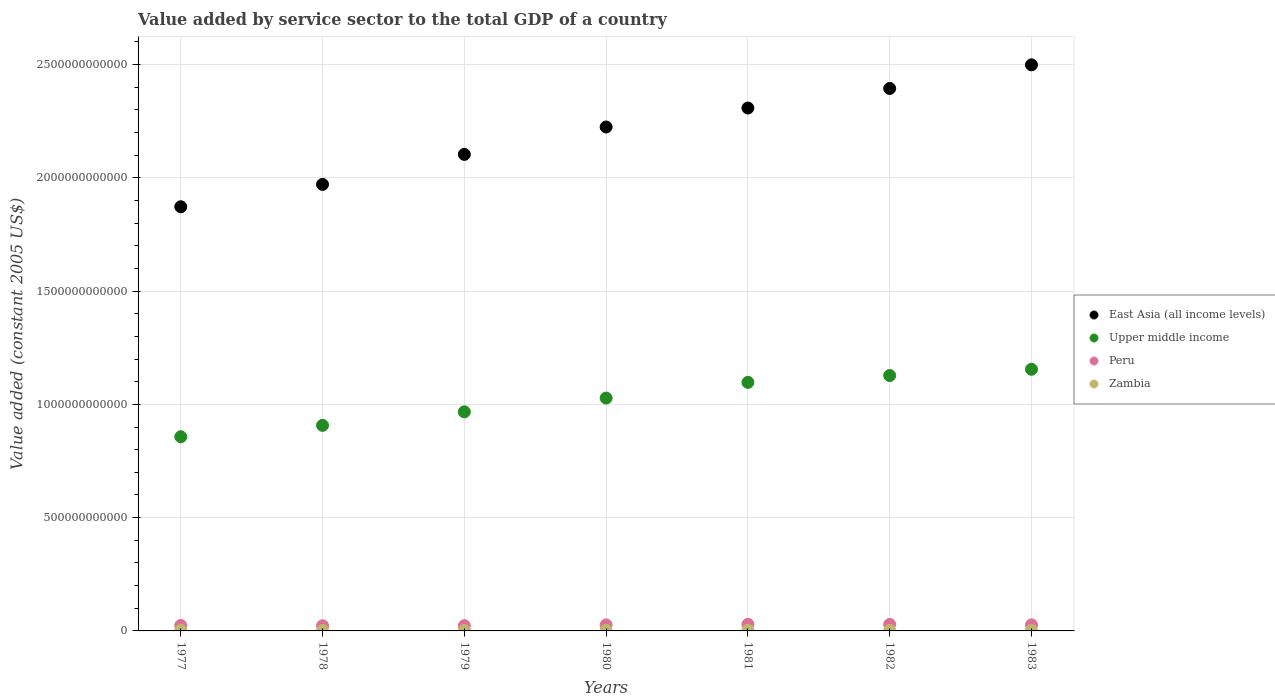Is the number of dotlines equal to the number of legend labels?
Offer a terse response. Yes. What is the value added by service sector in East Asia (all income levels) in 1979?
Your answer should be very brief. 2.10e+12. Across all years, what is the maximum value added by service sector in Peru?
Provide a succinct answer. 2.92e+1. Across all years, what is the minimum value added by service sector in Upper middle income?
Provide a succinct answer. 8.57e+11. In which year was the value added by service sector in Peru maximum?
Offer a very short reply. 1981. In which year was the value added by service sector in Peru minimum?
Your response must be concise. 1978. What is the total value added by service sector in Zambia in the graph?
Your answer should be compact. 1.52e+1. What is the difference between the value added by service sector in East Asia (all income levels) in 1977 and that in 1979?
Your answer should be very brief. -2.31e+11. What is the difference between the value added by service sector in Zambia in 1983 and the value added by service sector in East Asia (all income levels) in 1980?
Offer a very short reply. -2.22e+12. What is the average value added by service sector in Upper middle income per year?
Provide a succinct answer. 1.02e+12. In the year 1980, what is the difference between the value added by service sector in Upper middle income and value added by service sector in Peru?
Make the answer very short. 1.00e+12. What is the ratio of the value added by service sector in Peru in 1981 to that in 1983?
Your answer should be very brief. 1.09. Is the difference between the value added by service sector in Upper middle income in 1977 and 1982 greater than the difference between the value added by service sector in Peru in 1977 and 1982?
Provide a short and direct response. No. What is the difference between the highest and the second highest value added by service sector in East Asia (all income levels)?
Make the answer very short. 1.04e+11. What is the difference between the highest and the lowest value added by service sector in East Asia (all income levels)?
Your answer should be very brief. 6.26e+11. Is the sum of the value added by service sector in Zambia in 1978 and 1979 greater than the maximum value added by service sector in Peru across all years?
Offer a very short reply. No. Is it the case that in every year, the sum of the value added by service sector in Peru and value added by service sector in East Asia (all income levels)  is greater than the sum of value added by service sector in Zambia and value added by service sector in Upper middle income?
Your answer should be very brief. Yes. How many years are there in the graph?
Give a very brief answer. 7. What is the difference between two consecutive major ticks on the Y-axis?
Offer a very short reply. 5.00e+11. Does the graph contain any zero values?
Ensure brevity in your answer.  No. Does the graph contain grids?
Your answer should be compact. Yes. How are the legend labels stacked?
Provide a short and direct response. Vertical. What is the title of the graph?
Offer a very short reply. Value added by service sector to the total GDP of a country. Does "San Marino" appear as one of the legend labels in the graph?
Ensure brevity in your answer.  No. What is the label or title of the X-axis?
Your response must be concise. Years. What is the label or title of the Y-axis?
Offer a terse response. Value added (constant 2005 US$). What is the Value added (constant 2005 US$) of East Asia (all income levels) in 1977?
Your answer should be compact. 1.87e+12. What is the Value added (constant 2005 US$) in Upper middle income in 1977?
Keep it short and to the point. 8.57e+11. What is the Value added (constant 2005 US$) of Peru in 1977?
Provide a short and direct response. 2.41e+1. What is the Value added (constant 2005 US$) in Zambia in 1977?
Offer a very short reply. 2.11e+09. What is the Value added (constant 2005 US$) of East Asia (all income levels) in 1978?
Give a very brief answer. 1.97e+12. What is the Value added (constant 2005 US$) in Upper middle income in 1978?
Offer a terse response. 9.07e+11. What is the Value added (constant 2005 US$) of Peru in 1978?
Ensure brevity in your answer.  2.28e+1. What is the Value added (constant 2005 US$) in Zambia in 1978?
Give a very brief answer. 1.97e+09. What is the Value added (constant 2005 US$) in East Asia (all income levels) in 1979?
Make the answer very short. 2.10e+12. What is the Value added (constant 2005 US$) in Upper middle income in 1979?
Offer a very short reply. 9.67e+11. What is the Value added (constant 2005 US$) in Peru in 1979?
Offer a very short reply. 2.33e+1. What is the Value added (constant 2005 US$) in Zambia in 1979?
Give a very brief answer. 2.06e+09. What is the Value added (constant 2005 US$) in East Asia (all income levels) in 1980?
Provide a succinct answer. 2.22e+12. What is the Value added (constant 2005 US$) of Upper middle income in 1980?
Give a very brief answer. 1.03e+12. What is the Value added (constant 2005 US$) of Peru in 1980?
Provide a short and direct response. 2.67e+1. What is the Value added (constant 2005 US$) of Zambia in 1980?
Ensure brevity in your answer.  2.27e+09. What is the Value added (constant 2005 US$) of East Asia (all income levels) in 1981?
Offer a very short reply. 2.31e+12. What is the Value added (constant 2005 US$) of Upper middle income in 1981?
Make the answer very short. 1.10e+12. What is the Value added (constant 2005 US$) in Peru in 1981?
Your response must be concise. 2.92e+1. What is the Value added (constant 2005 US$) of Zambia in 1981?
Give a very brief answer. 2.44e+09. What is the Value added (constant 2005 US$) in East Asia (all income levels) in 1982?
Your response must be concise. 2.39e+12. What is the Value added (constant 2005 US$) in Upper middle income in 1982?
Keep it short and to the point. 1.13e+12. What is the Value added (constant 2005 US$) in Peru in 1982?
Provide a succinct answer. 2.89e+1. What is the Value added (constant 2005 US$) in Zambia in 1982?
Give a very brief answer. 2.26e+09. What is the Value added (constant 2005 US$) in East Asia (all income levels) in 1983?
Provide a succinct answer. 2.50e+12. What is the Value added (constant 2005 US$) of Upper middle income in 1983?
Keep it short and to the point. 1.15e+12. What is the Value added (constant 2005 US$) in Peru in 1983?
Your response must be concise. 2.67e+1. What is the Value added (constant 2005 US$) of Zambia in 1983?
Offer a very short reply. 2.05e+09. Across all years, what is the maximum Value added (constant 2005 US$) of East Asia (all income levels)?
Keep it short and to the point. 2.50e+12. Across all years, what is the maximum Value added (constant 2005 US$) in Upper middle income?
Keep it short and to the point. 1.15e+12. Across all years, what is the maximum Value added (constant 2005 US$) of Peru?
Provide a short and direct response. 2.92e+1. Across all years, what is the maximum Value added (constant 2005 US$) of Zambia?
Ensure brevity in your answer.  2.44e+09. Across all years, what is the minimum Value added (constant 2005 US$) of East Asia (all income levels)?
Your response must be concise. 1.87e+12. Across all years, what is the minimum Value added (constant 2005 US$) in Upper middle income?
Keep it short and to the point. 8.57e+11. Across all years, what is the minimum Value added (constant 2005 US$) in Peru?
Keep it short and to the point. 2.28e+1. Across all years, what is the minimum Value added (constant 2005 US$) in Zambia?
Keep it short and to the point. 1.97e+09. What is the total Value added (constant 2005 US$) of East Asia (all income levels) in the graph?
Your response must be concise. 1.54e+13. What is the total Value added (constant 2005 US$) in Upper middle income in the graph?
Your answer should be very brief. 7.14e+12. What is the total Value added (constant 2005 US$) of Peru in the graph?
Your response must be concise. 1.82e+11. What is the total Value added (constant 2005 US$) in Zambia in the graph?
Your response must be concise. 1.52e+1. What is the difference between the Value added (constant 2005 US$) in East Asia (all income levels) in 1977 and that in 1978?
Your answer should be compact. -9.86e+1. What is the difference between the Value added (constant 2005 US$) of Upper middle income in 1977 and that in 1978?
Offer a terse response. -5.01e+1. What is the difference between the Value added (constant 2005 US$) of Peru in 1977 and that in 1978?
Your answer should be very brief. 1.22e+09. What is the difference between the Value added (constant 2005 US$) in Zambia in 1977 and that in 1978?
Your response must be concise. 1.35e+08. What is the difference between the Value added (constant 2005 US$) of East Asia (all income levels) in 1977 and that in 1979?
Provide a succinct answer. -2.31e+11. What is the difference between the Value added (constant 2005 US$) in Upper middle income in 1977 and that in 1979?
Your response must be concise. -1.10e+11. What is the difference between the Value added (constant 2005 US$) of Peru in 1977 and that in 1979?
Keep it short and to the point. 8.03e+08. What is the difference between the Value added (constant 2005 US$) in Zambia in 1977 and that in 1979?
Offer a very short reply. 5.19e+07. What is the difference between the Value added (constant 2005 US$) in East Asia (all income levels) in 1977 and that in 1980?
Keep it short and to the point. -3.52e+11. What is the difference between the Value added (constant 2005 US$) of Upper middle income in 1977 and that in 1980?
Offer a very short reply. -1.71e+11. What is the difference between the Value added (constant 2005 US$) in Peru in 1977 and that in 1980?
Your answer should be very brief. -2.62e+09. What is the difference between the Value added (constant 2005 US$) of Zambia in 1977 and that in 1980?
Keep it short and to the point. -1.61e+08. What is the difference between the Value added (constant 2005 US$) of East Asia (all income levels) in 1977 and that in 1981?
Provide a succinct answer. -4.36e+11. What is the difference between the Value added (constant 2005 US$) in Upper middle income in 1977 and that in 1981?
Offer a very short reply. -2.40e+11. What is the difference between the Value added (constant 2005 US$) in Peru in 1977 and that in 1981?
Offer a very short reply. -5.09e+09. What is the difference between the Value added (constant 2005 US$) of Zambia in 1977 and that in 1981?
Your answer should be compact. -3.27e+08. What is the difference between the Value added (constant 2005 US$) of East Asia (all income levels) in 1977 and that in 1982?
Make the answer very short. -5.22e+11. What is the difference between the Value added (constant 2005 US$) in Upper middle income in 1977 and that in 1982?
Provide a succinct answer. -2.70e+11. What is the difference between the Value added (constant 2005 US$) of Peru in 1977 and that in 1982?
Ensure brevity in your answer.  -4.81e+09. What is the difference between the Value added (constant 2005 US$) in Zambia in 1977 and that in 1982?
Give a very brief answer. -1.55e+08. What is the difference between the Value added (constant 2005 US$) of East Asia (all income levels) in 1977 and that in 1983?
Offer a very short reply. -6.26e+11. What is the difference between the Value added (constant 2005 US$) of Upper middle income in 1977 and that in 1983?
Offer a terse response. -2.98e+11. What is the difference between the Value added (constant 2005 US$) of Peru in 1977 and that in 1983?
Offer a terse response. -2.67e+09. What is the difference between the Value added (constant 2005 US$) of Zambia in 1977 and that in 1983?
Ensure brevity in your answer.  6.34e+07. What is the difference between the Value added (constant 2005 US$) in East Asia (all income levels) in 1978 and that in 1979?
Provide a short and direct response. -1.33e+11. What is the difference between the Value added (constant 2005 US$) in Upper middle income in 1978 and that in 1979?
Offer a very short reply. -5.97e+1. What is the difference between the Value added (constant 2005 US$) of Peru in 1978 and that in 1979?
Offer a very short reply. -4.20e+08. What is the difference between the Value added (constant 2005 US$) of Zambia in 1978 and that in 1979?
Provide a succinct answer. -8.29e+07. What is the difference between the Value added (constant 2005 US$) in East Asia (all income levels) in 1978 and that in 1980?
Your answer should be compact. -2.53e+11. What is the difference between the Value added (constant 2005 US$) of Upper middle income in 1978 and that in 1980?
Ensure brevity in your answer.  -1.21e+11. What is the difference between the Value added (constant 2005 US$) in Peru in 1978 and that in 1980?
Ensure brevity in your answer.  -3.84e+09. What is the difference between the Value added (constant 2005 US$) in Zambia in 1978 and that in 1980?
Make the answer very short. -2.95e+08. What is the difference between the Value added (constant 2005 US$) of East Asia (all income levels) in 1978 and that in 1981?
Your answer should be very brief. -3.37e+11. What is the difference between the Value added (constant 2005 US$) in Upper middle income in 1978 and that in 1981?
Offer a terse response. -1.90e+11. What is the difference between the Value added (constant 2005 US$) of Peru in 1978 and that in 1981?
Ensure brevity in your answer.  -6.31e+09. What is the difference between the Value added (constant 2005 US$) in Zambia in 1978 and that in 1981?
Give a very brief answer. -4.61e+08. What is the difference between the Value added (constant 2005 US$) in East Asia (all income levels) in 1978 and that in 1982?
Your answer should be very brief. -4.24e+11. What is the difference between the Value added (constant 2005 US$) of Upper middle income in 1978 and that in 1982?
Provide a short and direct response. -2.20e+11. What is the difference between the Value added (constant 2005 US$) in Peru in 1978 and that in 1982?
Provide a succinct answer. -6.03e+09. What is the difference between the Value added (constant 2005 US$) in Zambia in 1978 and that in 1982?
Make the answer very short. -2.89e+08. What is the difference between the Value added (constant 2005 US$) of East Asia (all income levels) in 1978 and that in 1983?
Keep it short and to the point. -5.28e+11. What is the difference between the Value added (constant 2005 US$) in Upper middle income in 1978 and that in 1983?
Give a very brief answer. -2.48e+11. What is the difference between the Value added (constant 2005 US$) in Peru in 1978 and that in 1983?
Make the answer very short. -3.89e+09. What is the difference between the Value added (constant 2005 US$) in Zambia in 1978 and that in 1983?
Provide a succinct answer. -7.14e+07. What is the difference between the Value added (constant 2005 US$) in East Asia (all income levels) in 1979 and that in 1980?
Make the answer very short. -1.21e+11. What is the difference between the Value added (constant 2005 US$) of Upper middle income in 1979 and that in 1980?
Give a very brief answer. -6.08e+1. What is the difference between the Value added (constant 2005 US$) in Peru in 1979 and that in 1980?
Your answer should be compact. -3.42e+09. What is the difference between the Value added (constant 2005 US$) of Zambia in 1979 and that in 1980?
Offer a very short reply. -2.12e+08. What is the difference between the Value added (constant 2005 US$) of East Asia (all income levels) in 1979 and that in 1981?
Your answer should be compact. -2.05e+11. What is the difference between the Value added (constant 2005 US$) of Upper middle income in 1979 and that in 1981?
Your response must be concise. -1.30e+11. What is the difference between the Value added (constant 2005 US$) of Peru in 1979 and that in 1981?
Your answer should be very brief. -5.89e+09. What is the difference between the Value added (constant 2005 US$) of Zambia in 1979 and that in 1981?
Keep it short and to the point. -3.79e+08. What is the difference between the Value added (constant 2005 US$) of East Asia (all income levels) in 1979 and that in 1982?
Offer a terse response. -2.91e+11. What is the difference between the Value added (constant 2005 US$) of Upper middle income in 1979 and that in 1982?
Your response must be concise. -1.60e+11. What is the difference between the Value added (constant 2005 US$) in Peru in 1979 and that in 1982?
Offer a terse response. -5.61e+09. What is the difference between the Value added (constant 2005 US$) of Zambia in 1979 and that in 1982?
Your answer should be very brief. -2.06e+08. What is the difference between the Value added (constant 2005 US$) of East Asia (all income levels) in 1979 and that in 1983?
Ensure brevity in your answer.  -3.95e+11. What is the difference between the Value added (constant 2005 US$) in Upper middle income in 1979 and that in 1983?
Your response must be concise. -1.88e+11. What is the difference between the Value added (constant 2005 US$) in Peru in 1979 and that in 1983?
Ensure brevity in your answer.  -3.47e+09. What is the difference between the Value added (constant 2005 US$) of Zambia in 1979 and that in 1983?
Your answer should be compact. 1.15e+07. What is the difference between the Value added (constant 2005 US$) of East Asia (all income levels) in 1980 and that in 1981?
Offer a terse response. -8.38e+1. What is the difference between the Value added (constant 2005 US$) of Upper middle income in 1980 and that in 1981?
Give a very brief answer. -6.93e+1. What is the difference between the Value added (constant 2005 US$) of Peru in 1980 and that in 1981?
Provide a short and direct response. -2.47e+09. What is the difference between the Value added (constant 2005 US$) in Zambia in 1980 and that in 1981?
Make the answer very short. -1.66e+08. What is the difference between the Value added (constant 2005 US$) of East Asia (all income levels) in 1980 and that in 1982?
Offer a very short reply. -1.70e+11. What is the difference between the Value added (constant 2005 US$) of Upper middle income in 1980 and that in 1982?
Offer a very short reply. -9.94e+1. What is the difference between the Value added (constant 2005 US$) of Peru in 1980 and that in 1982?
Provide a short and direct response. -2.19e+09. What is the difference between the Value added (constant 2005 US$) in Zambia in 1980 and that in 1982?
Provide a succinct answer. 6.07e+06. What is the difference between the Value added (constant 2005 US$) in East Asia (all income levels) in 1980 and that in 1983?
Offer a terse response. -2.74e+11. What is the difference between the Value added (constant 2005 US$) of Upper middle income in 1980 and that in 1983?
Provide a succinct answer. -1.27e+11. What is the difference between the Value added (constant 2005 US$) of Peru in 1980 and that in 1983?
Ensure brevity in your answer.  -4.51e+07. What is the difference between the Value added (constant 2005 US$) of Zambia in 1980 and that in 1983?
Your answer should be very brief. 2.24e+08. What is the difference between the Value added (constant 2005 US$) of East Asia (all income levels) in 1981 and that in 1982?
Your answer should be compact. -8.63e+1. What is the difference between the Value added (constant 2005 US$) in Upper middle income in 1981 and that in 1982?
Ensure brevity in your answer.  -3.01e+1. What is the difference between the Value added (constant 2005 US$) in Peru in 1981 and that in 1982?
Keep it short and to the point. 2.77e+08. What is the difference between the Value added (constant 2005 US$) of Zambia in 1981 and that in 1982?
Keep it short and to the point. 1.72e+08. What is the difference between the Value added (constant 2005 US$) in East Asia (all income levels) in 1981 and that in 1983?
Your answer should be compact. -1.91e+11. What is the difference between the Value added (constant 2005 US$) in Upper middle income in 1981 and that in 1983?
Offer a terse response. -5.78e+1. What is the difference between the Value added (constant 2005 US$) in Peru in 1981 and that in 1983?
Your answer should be compact. 2.42e+09. What is the difference between the Value added (constant 2005 US$) in Zambia in 1981 and that in 1983?
Provide a short and direct response. 3.90e+08. What is the difference between the Value added (constant 2005 US$) of East Asia (all income levels) in 1982 and that in 1983?
Provide a short and direct response. -1.04e+11. What is the difference between the Value added (constant 2005 US$) in Upper middle income in 1982 and that in 1983?
Provide a succinct answer. -2.77e+1. What is the difference between the Value added (constant 2005 US$) in Peru in 1982 and that in 1983?
Your answer should be compact. 2.14e+09. What is the difference between the Value added (constant 2005 US$) of Zambia in 1982 and that in 1983?
Offer a terse response. 2.18e+08. What is the difference between the Value added (constant 2005 US$) of East Asia (all income levels) in 1977 and the Value added (constant 2005 US$) of Upper middle income in 1978?
Offer a terse response. 9.65e+11. What is the difference between the Value added (constant 2005 US$) in East Asia (all income levels) in 1977 and the Value added (constant 2005 US$) in Peru in 1978?
Your answer should be very brief. 1.85e+12. What is the difference between the Value added (constant 2005 US$) in East Asia (all income levels) in 1977 and the Value added (constant 2005 US$) in Zambia in 1978?
Your answer should be very brief. 1.87e+12. What is the difference between the Value added (constant 2005 US$) in Upper middle income in 1977 and the Value added (constant 2005 US$) in Peru in 1978?
Your response must be concise. 8.34e+11. What is the difference between the Value added (constant 2005 US$) in Upper middle income in 1977 and the Value added (constant 2005 US$) in Zambia in 1978?
Ensure brevity in your answer.  8.55e+11. What is the difference between the Value added (constant 2005 US$) in Peru in 1977 and the Value added (constant 2005 US$) in Zambia in 1978?
Offer a terse response. 2.21e+1. What is the difference between the Value added (constant 2005 US$) of East Asia (all income levels) in 1977 and the Value added (constant 2005 US$) of Upper middle income in 1979?
Offer a terse response. 9.05e+11. What is the difference between the Value added (constant 2005 US$) of East Asia (all income levels) in 1977 and the Value added (constant 2005 US$) of Peru in 1979?
Give a very brief answer. 1.85e+12. What is the difference between the Value added (constant 2005 US$) of East Asia (all income levels) in 1977 and the Value added (constant 2005 US$) of Zambia in 1979?
Offer a terse response. 1.87e+12. What is the difference between the Value added (constant 2005 US$) in Upper middle income in 1977 and the Value added (constant 2005 US$) in Peru in 1979?
Your answer should be very brief. 8.34e+11. What is the difference between the Value added (constant 2005 US$) in Upper middle income in 1977 and the Value added (constant 2005 US$) in Zambia in 1979?
Keep it short and to the point. 8.55e+11. What is the difference between the Value added (constant 2005 US$) of Peru in 1977 and the Value added (constant 2005 US$) of Zambia in 1979?
Offer a terse response. 2.20e+1. What is the difference between the Value added (constant 2005 US$) of East Asia (all income levels) in 1977 and the Value added (constant 2005 US$) of Upper middle income in 1980?
Your answer should be very brief. 8.44e+11. What is the difference between the Value added (constant 2005 US$) of East Asia (all income levels) in 1977 and the Value added (constant 2005 US$) of Peru in 1980?
Ensure brevity in your answer.  1.85e+12. What is the difference between the Value added (constant 2005 US$) in East Asia (all income levels) in 1977 and the Value added (constant 2005 US$) in Zambia in 1980?
Your response must be concise. 1.87e+12. What is the difference between the Value added (constant 2005 US$) in Upper middle income in 1977 and the Value added (constant 2005 US$) in Peru in 1980?
Provide a short and direct response. 8.31e+11. What is the difference between the Value added (constant 2005 US$) in Upper middle income in 1977 and the Value added (constant 2005 US$) in Zambia in 1980?
Give a very brief answer. 8.55e+11. What is the difference between the Value added (constant 2005 US$) in Peru in 1977 and the Value added (constant 2005 US$) in Zambia in 1980?
Your answer should be very brief. 2.18e+1. What is the difference between the Value added (constant 2005 US$) of East Asia (all income levels) in 1977 and the Value added (constant 2005 US$) of Upper middle income in 1981?
Keep it short and to the point. 7.75e+11. What is the difference between the Value added (constant 2005 US$) of East Asia (all income levels) in 1977 and the Value added (constant 2005 US$) of Peru in 1981?
Give a very brief answer. 1.84e+12. What is the difference between the Value added (constant 2005 US$) in East Asia (all income levels) in 1977 and the Value added (constant 2005 US$) in Zambia in 1981?
Offer a terse response. 1.87e+12. What is the difference between the Value added (constant 2005 US$) of Upper middle income in 1977 and the Value added (constant 2005 US$) of Peru in 1981?
Your answer should be very brief. 8.28e+11. What is the difference between the Value added (constant 2005 US$) in Upper middle income in 1977 and the Value added (constant 2005 US$) in Zambia in 1981?
Your answer should be very brief. 8.55e+11. What is the difference between the Value added (constant 2005 US$) in Peru in 1977 and the Value added (constant 2005 US$) in Zambia in 1981?
Provide a short and direct response. 2.16e+1. What is the difference between the Value added (constant 2005 US$) in East Asia (all income levels) in 1977 and the Value added (constant 2005 US$) in Upper middle income in 1982?
Your response must be concise. 7.45e+11. What is the difference between the Value added (constant 2005 US$) of East Asia (all income levels) in 1977 and the Value added (constant 2005 US$) of Peru in 1982?
Provide a short and direct response. 1.84e+12. What is the difference between the Value added (constant 2005 US$) of East Asia (all income levels) in 1977 and the Value added (constant 2005 US$) of Zambia in 1982?
Offer a very short reply. 1.87e+12. What is the difference between the Value added (constant 2005 US$) of Upper middle income in 1977 and the Value added (constant 2005 US$) of Peru in 1982?
Ensure brevity in your answer.  8.28e+11. What is the difference between the Value added (constant 2005 US$) of Upper middle income in 1977 and the Value added (constant 2005 US$) of Zambia in 1982?
Provide a succinct answer. 8.55e+11. What is the difference between the Value added (constant 2005 US$) in Peru in 1977 and the Value added (constant 2005 US$) in Zambia in 1982?
Keep it short and to the point. 2.18e+1. What is the difference between the Value added (constant 2005 US$) of East Asia (all income levels) in 1977 and the Value added (constant 2005 US$) of Upper middle income in 1983?
Your answer should be very brief. 7.17e+11. What is the difference between the Value added (constant 2005 US$) of East Asia (all income levels) in 1977 and the Value added (constant 2005 US$) of Peru in 1983?
Offer a terse response. 1.85e+12. What is the difference between the Value added (constant 2005 US$) of East Asia (all income levels) in 1977 and the Value added (constant 2005 US$) of Zambia in 1983?
Your answer should be very brief. 1.87e+12. What is the difference between the Value added (constant 2005 US$) in Upper middle income in 1977 and the Value added (constant 2005 US$) in Peru in 1983?
Provide a short and direct response. 8.30e+11. What is the difference between the Value added (constant 2005 US$) in Upper middle income in 1977 and the Value added (constant 2005 US$) in Zambia in 1983?
Provide a short and direct response. 8.55e+11. What is the difference between the Value added (constant 2005 US$) of Peru in 1977 and the Value added (constant 2005 US$) of Zambia in 1983?
Give a very brief answer. 2.20e+1. What is the difference between the Value added (constant 2005 US$) in East Asia (all income levels) in 1978 and the Value added (constant 2005 US$) in Upper middle income in 1979?
Your response must be concise. 1.00e+12. What is the difference between the Value added (constant 2005 US$) of East Asia (all income levels) in 1978 and the Value added (constant 2005 US$) of Peru in 1979?
Your answer should be very brief. 1.95e+12. What is the difference between the Value added (constant 2005 US$) of East Asia (all income levels) in 1978 and the Value added (constant 2005 US$) of Zambia in 1979?
Make the answer very short. 1.97e+12. What is the difference between the Value added (constant 2005 US$) of Upper middle income in 1978 and the Value added (constant 2005 US$) of Peru in 1979?
Keep it short and to the point. 8.84e+11. What is the difference between the Value added (constant 2005 US$) in Upper middle income in 1978 and the Value added (constant 2005 US$) in Zambia in 1979?
Your answer should be very brief. 9.05e+11. What is the difference between the Value added (constant 2005 US$) in Peru in 1978 and the Value added (constant 2005 US$) in Zambia in 1979?
Provide a short and direct response. 2.08e+1. What is the difference between the Value added (constant 2005 US$) in East Asia (all income levels) in 1978 and the Value added (constant 2005 US$) in Upper middle income in 1980?
Provide a short and direct response. 9.43e+11. What is the difference between the Value added (constant 2005 US$) of East Asia (all income levels) in 1978 and the Value added (constant 2005 US$) of Peru in 1980?
Your response must be concise. 1.94e+12. What is the difference between the Value added (constant 2005 US$) in East Asia (all income levels) in 1978 and the Value added (constant 2005 US$) in Zambia in 1980?
Your response must be concise. 1.97e+12. What is the difference between the Value added (constant 2005 US$) of Upper middle income in 1978 and the Value added (constant 2005 US$) of Peru in 1980?
Your answer should be very brief. 8.81e+11. What is the difference between the Value added (constant 2005 US$) of Upper middle income in 1978 and the Value added (constant 2005 US$) of Zambia in 1980?
Give a very brief answer. 9.05e+11. What is the difference between the Value added (constant 2005 US$) in Peru in 1978 and the Value added (constant 2005 US$) in Zambia in 1980?
Provide a succinct answer. 2.06e+1. What is the difference between the Value added (constant 2005 US$) in East Asia (all income levels) in 1978 and the Value added (constant 2005 US$) in Upper middle income in 1981?
Your answer should be very brief. 8.74e+11. What is the difference between the Value added (constant 2005 US$) of East Asia (all income levels) in 1978 and the Value added (constant 2005 US$) of Peru in 1981?
Give a very brief answer. 1.94e+12. What is the difference between the Value added (constant 2005 US$) of East Asia (all income levels) in 1978 and the Value added (constant 2005 US$) of Zambia in 1981?
Provide a succinct answer. 1.97e+12. What is the difference between the Value added (constant 2005 US$) of Upper middle income in 1978 and the Value added (constant 2005 US$) of Peru in 1981?
Keep it short and to the point. 8.78e+11. What is the difference between the Value added (constant 2005 US$) in Upper middle income in 1978 and the Value added (constant 2005 US$) in Zambia in 1981?
Keep it short and to the point. 9.05e+11. What is the difference between the Value added (constant 2005 US$) of Peru in 1978 and the Value added (constant 2005 US$) of Zambia in 1981?
Provide a short and direct response. 2.04e+1. What is the difference between the Value added (constant 2005 US$) in East Asia (all income levels) in 1978 and the Value added (constant 2005 US$) in Upper middle income in 1982?
Offer a terse response. 8.44e+11. What is the difference between the Value added (constant 2005 US$) in East Asia (all income levels) in 1978 and the Value added (constant 2005 US$) in Peru in 1982?
Your response must be concise. 1.94e+12. What is the difference between the Value added (constant 2005 US$) of East Asia (all income levels) in 1978 and the Value added (constant 2005 US$) of Zambia in 1982?
Provide a short and direct response. 1.97e+12. What is the difference between the Value added (constant 2005 US$) in Upper middle income in 1978 and the Value added (constant 2005 US$) in Peru in 1982?
Your answer should be very brief. 8.78e+11. What is the difference between the Value added (constant 2005 US$) in Upper middle income in 1978 and the Value added (constant 2005 US$) in Zambia in 1982?
Give a very brief answer. 9.05e+11. What is the difference between the Value added (constant 2005 US$) of Peru in 1978 and the Value added (constant 2005 US$) of Zambia in 1982?
Your answer should be very brief. 2.06e+1. What is the difference between the Value added (constant 2005 US$) of East Asia (all income levels) in 1978 and the Value added (constant 2005 US$) of Upper middle income in 1983?
Your response must be concise. 8.16e+11. What is the difference between the Value added (constant 2005 US$) in East Asia (all income levels) in 1978 and the Value added (constant 2005 US$) in Peru in 1983?
Your answer should be very brief. 1.94e+12. What is the difference between the Value added (constant 2005 US$) in East Asia (all income levels) in 1978 and the Value added (constant 2005 US$) in Zambia in 1983?
Your answer should be compact. 1.97e+12. What is the difference between the Value added (constant 2005 US$) in Upper middle income in 1978 and the Value added (constant 2005 US$) in Peru in 1983?
Provide a short and direct response. 8.81e+11. What is the difference between the Value added (constant 2005 US$) of Upper middle income in 1978 and the Value added (constant 2005 US$) of Zambia in 1983?
Offer a very short reply. 9.05e+11. What is the difference between the Value added (constant 2005 US$) of Peru in 1978 and the Value added (constant 2005 US$) of Zambia in 1983?
Offer a very short reply. 2.08e+1. What is the difference between the Value added (constant 2005 US$) of East Asia (all income levels) in 1979 and the Value added (constant 2005 US$) of Upper middle income in 1980?
Offer a very short reply. 1.08e+12. What is the difference between the Value added (constant 2005 US$) of East Asia (all income levels) in 1979 and the Value added (constant 2005 US$) of Peru in 1980?
Give a very brief answer. 2.08e+12. What is the difference between the Value added (constant 2005 US$) of East Asia (all income levels) in 1979 and the Value added (constant 2005 US$) of Zambia in 1980?
Provide a short and direct response. 2.10e+12. What is the difference between the Value added (constant 2005 US$) in Upper middle income in 1979 and the Value added (constant 2005 US$) in Peru in 1980?
Provide a succinct answer. 9.40e+11. What is the difference between the Value added (constant 2005 US$) in Upper middle income in 1979 and the Value added (constant 2005 US$) in Zambia in 1980?
Your answer should be compact. 9.65e+11. What is the difference between the Value added (constant 2005 US$) of Peru in 1979 and the Value added (constant 2005 US$) of Zambia in 1980?
Offer a terse response. 2.10e+1. What is the difference between the Value added (constant 2005 US$) in East Asia (all income levels) in 1979 and the Value added (constant 2005 US$) in Upper middle income in 1981?
Keep it short and to the point. 1.01e+12. What is the difference between the Value added (constant 2005 US$) in East Asia (all income levels) in 1979 and the Value added (constant 2005 US$) in Peru in 1981?
Offer a very short reply. 2.07e+12. What is the difference between the Value added (constant 2005 US$) in East Asia (all income levels) in 1979 and the Value added (constant 2005 US$) in Zambia in 1981?
Keep it short and to the point. 2.10e+12. What is the difference between the Value added (constant 2005 US$) of Upper middle income in 1979 and the Value added (constant 2005 US$) of Peru in 1981?
Make the answer very short. 9.38e+11. What is the difference between the Value added (constant 2005 US$) in Upper middle income in 1979 and the Value added (constant 2005 US$) in Zambia in 1981?
Make the answer very short. 9.65e+11. What is the difference between the Value added (constant 2005 US$) in Peru in 1979 and the Value added (constant 2005 US$) in Zambia in 1981?
Provide a succinct answer. 2.08e+1. What is the difference between the Value added (constant 2005 US$) of East Asia (all income levels) in 1979 and the Value added (constant 2005 US$) of Upper middle income in 1982?
Provide a short and direct response. 9.76e+11. What is the difference between the Value added (constant 2005 US$) in East Asia (all income levels) in 1979 and the Value added (constant 2005 US$) in Peru in 1982?
Your answer should be compact. 2.07e+12. What is the difference between the Value added (constant 2005 US$) in East Asia (all income levels) in 1979 and the Value added (constant 2005 US$) in Zambia in 1982?
Your answer should be very brief. 2.10e+12. What is the difference between the Value added (constant 2005 US$) of Upper middle income in 1979 and the Value added (constant 2005 US$) of Peru in 1982?
Make the answer very short. 9.38e+11. What is the difference between the Value added (constant 2005 US$) in Upper middle income in 1979 and the Value added (constant 2005 US$) in Zambia in 1982?
Provide a succinct answer. 9.65e+11. What is the difference between the Value added (constant 2005 US$) of Peru in 1979 and the Value added (constant 2005 US$) of Zambia in 1982?
Your response must be concise. 2.10e+1. What is the difference between the Value added (constant 2005 US$) of East Asia (all income levels) in 1979 and the Value added (constant 2005 US$) of Upper middle income in 1983?
Ensure brevity in your answer.  9.49e+11. What is the difference between the Value added (constant 2005 US$) in East Asia (all income levels) in 1979 and the Value added (constant 2005 US$) in Peru in 1983?
Make the answer very short. 2.08e+12. What is the difference between the Value added (constant 2005 US$) in East Asia (all income levels) in 1979 and the Value added (constant 2005 US$) in Zambia in 1983?
Give a very brief answer. 2.10e+12. What is the difference between the Value added (constant 2005 US$) of Upper middle income in 1979 and the Value added (constant 2005 US$) of Peru in 1983?
Provide a short and direct response. 9.40e+11. What is the difference between the Value added (constant 2005 US$) of Upper middle income in 1979 and the Value added (constant 2005 US$) of Zambia in 1983?
Provide a short and direct response. 9.65e+11. What is the difference between the Value added (constant 2005 US$) in Peru in 1979 and the Value added (constant 2005 US$) in Zambia in 1983?
Provide a short and direct response. 2.12e+1. What is the difference between the Value added (constant 2005 US$) of East Asia (all income levels) in 1980 and the Value added (constant 2005 US$) of Upper middle income in 1981?
Offer a terse response. 1.13e+12. What is the difference between the Value added (constant 2005 US$) of East Asia (all income levels) in 1980 and the Value added (constant 2005 US$) of Peru in 1981?
Give a very brief answer. 2.20e+12. What is the difference between the Value added (constant 2005 US$) of East Asia (all income levels) in 1980 and the Value added (constant 2005 US$) of Zambia in 1981?
Give a very brief answer. 2.22e+12. What is the difference between the Value added (constant 2005 US$) of Upper middle income in 1980 and the Value added (constant 2005 US$) of Peru in 1981?
Offer a very short reply. 9.99e+11. What is the difference between the Value added (constant 2005 US$) of Upper middle income in 1980 and the Value added (constant 2005 US$) of Zambia in 1981?
Offer a very short reply. 1.03e+12. What is the difference between the Value added (constant 2005 US$) of Peru in 1980 and the Value added (constant 2005 US$) of Zambia in 1981?
Make the answer very short. 2.43e+1. What is the difference between the Value added (constant 2005 US$) in East Asia (all income levels) in 1980 and the Value added (constant 2005 US$) in Upper middle income in 1982?
Provide a short and direct response. 1.10e+12. What is the difference between the Value added (constant 2005 US$) of East Asia (all income levels) in 1980 and the Value added (constant 2005 US$) of Peru in 1982?
Make the answer very short. 2.20e+12. What is the difference between the Value added (constant 2005 US$) of East Asia (all income levels) in 1980 and the Value added (constant 2005 US$) of Zambia in 1982?
Your answer should be compact. 2.22e+12. What is the difference between the Value added (constant 2005 US$) in Upper middle income in 1980 and the Value added (constant 2005 US$) in Peru in 1982?
Keep it short and to the point. 9.99e+11. What is the difference between the Value added (constant 2005 US$) of Upper middle income in 1980 and the Value added (constant 2005 US$) of Zambia in 1982?
Your answer should be very brief. 1.03e+12. What is the difference between the Value added (constant 2005 US$) in Peru in 1980 and the Value added (constant 2005 US$) in Zambia in 1982?
Offer a very short reply. 2.44e+1. What is the difference between the Value added (constant 2005 US$) of East Asia (all income levels) in 1980 and the Value added (constant 2005 US$) of Upper middle income in 1983?
Your response must be concise. 1.07e+12. What is the difference between the Value added (constant 2005 US$) in East Asia (all income levels) in 1980 and the Value added (constant 2005 US$) in Peru in 1983?
Ensure brevity in your answer.  2.20e+12. What is the difference between the Value added (constant 2005 US$) in East Asia (all income levels) in 1980 and the Value added (constant 2005 US$) in Zambia in 1983?
Your answer should be compact. 2.22e+12. What is the difference between the Value added (constant 2005 US$) of Upper middle income in 1980 and the Value added (constant 2005 US$) of Peru in 1983?
Offer a very short reply. 1.00e+12. What is the difference between the Value added (constant 2005 US$) of Upper middle income in 1980 and the Value added (constant 2005 US$) of Zambia in 1983?
Offer a terse response. 1.03e+12. What is the difference between the Value added (constant 2005 US$) of Peru in 1980 and the Value added (constant 2005 US$) of Zambia in 1983?
Keep it short and to the point. 2.46e+1. What is the difference between the Value added (constant 2005 US$) in East Asia (all income levels) in 1981 and the Value added (constant 2005 US$) in Upper middle income in 1982?
Keep it short and to the point. 1.18e+12. What is the difference between the Value added (constant 2005 US$) of East Asia (all income levels) in 1981 and the Value added (constant 2005 US$) of Peru in 1982?
Your response must be concise. 2.28e+12. What is the difference between the Value added (constant 2005 US$) of East Asia (all income levels) in 1981 and the Value added (constant 2005 US$) of Zambia in 1982?
Ensure brevity in your answer.  2.31e+12. What is the difference between the Value added (constant 2005 US$) in Upper middle income in 1981 and the Value added (constant 2005 US$) in Peru in 1982?
Keep it short and to the point. 1.07e+12. What is the difference between the Value added (constant 2005 US$) in Upper middle income in 1981 and the Value added (constant 2005 US$) in Zambia in 1982?
Give a very brief answer. 1.09e+12. What is the difference between the Value added (constant 2005 US$) in Peru in 1981 and the Value added (constant 2005 US$) in Zambia in 1982?
Offer a terse response. 2.69e+1. What is the difference between the Value added (constant 2005 US$) in East Asia (all income levels) in 1981 and the Value added (constant 2005 US$) in Upper middle income in 1983?
Your answer should be compact. 1.15e+12. What is the difference between the Value added (constant 2005 US$) of East Asia (all income levels) in 1981 and the Value added (constant 2005 US$) of Peru in 1983?
Offer a terse response. 2.28e+12. What is the difference between the Value added (constant 2005 US$) of East Asia (all income levels) in 1981 and the Value added (constant 2005 US$) of Zambia in 1983?
Provide a short and direct response. 2.31e+12. What is the difference between the Value added (constant 2005 US$) in Upper middle income in 1981 and the Value added (constant 2005 US$) in Peru in 1983?
Give a very brief answer. 1.07e+12. What is the difference between the Value added (constant 2005 US$) of Upper middle income in 1981 and the Value added (constant 2005 US$) of Zambia in 1983?
Your answer should be very brief. 1.10e+12. What is the difference between the Value added (constant 2005 US$) in Peru in 1981 and the Value added (constant 2005 US$) in Zambia in 1983?
Provide a short and direct response. 2.71e+1. What is the difference between the Value added (constant 2005 US$) of East Asia (all income levels) in 1982 and the Value added (constant 2005 US$) of Upper middle income in 1983?
Provide a succinct answer. 1.24e+12. What is the difference between the Value added (constant 2005 US$) in East Asia (all income levels) in 1982 and the Value added (constant 2005 US$) in Peru in 1983?
Provide a short and direct response. 2.37e+12. What is the difference between the Value added (constant 2005 US$) of East Asia (all income levels) in 1982 and the Value added (constant 2005 US$) of Zambia in 1983?
Make the answer very short. 2.39e+12. What is the difference between the Value added (constant 2005 US$) of Upper middle income in 1982 and the Value added (constant 2005 US$) of Peru in 1983?
Make the answer very short. 1.10e+12. What is the difference between the Value added (constant 2005 US$) of Upper middle income in 1982 and the Value added (constant 2005 US$) of Zambia in 1983?
Your answer should be very brief. 1.13e+12. What is the difference between the Value added (constant 2005 US$) of Peru in 1982 and the Value added (constant 2005 US$) of Zambia in 1983?
Provide a short and direct response. 2.68e+1. What is the average Value added (constant 2005 US$) in East Asia (all income levels) per year?
Your answer should be compact. 2.20e+12. What is the average Value added (constant 2005 US$) in Upper middle income per year?
Keep it short and to the point. 1.02e+12. What is the average Value added (constant 2005 US$) in Peru per year?
Your answer should be compact. 2.59e+1. What is the average Value added (constant 2005 US$) of Zambia per year?
Keep it short and to the point. 2.17e+09. In the year 1977, what is the difference between the Value added (constant 2005 US$) of East Asia (all income levels) and Value added (constant 2005 US$) of Upper middle income?
Provide a short and direct response. 1.02e+12. In the year 1977, what is the difference between the Value added (constant 2005 US$) in East Asia (all income levels) and Value added (constant 2005 US$) in Peru?
Your answer should be very brief. 1.85e+12. In the year 1977, what is the difference between the Value added (constant 2005 US$) in East Asia (all income levels) and Value added (constant 2005 US$) in Zambia?
Give a very brief answer. 1.87e+12. In the year 1977, what is the difference between the Value added (constant 2005 US$) in Upper middle income and Value added (constant 2005 US$) in Peru?
Give a very brief answer. 8.33e+11. In the year 1977, what is the difference between the Value added (constant 2005 US$) in Upper middle income and Value added (constant 2005 US$) in Zambia?
Your answer should be compact. 8.55e+11. In the year 1977, what is the difference between the Value added (constant 2005 US$) of Peru and Value added (constant 2005 US$) of Zambia?
Offer a terse response. 2.20e+1. In the year 1978, what is the difference between the Value added (constant 2005 US$) of East Asia (all income levels) and Value added (constant 2005 US$) of Upper middle income?
Your answer should be compact. 1.06e+12. In the year 1978, what is the difference between the Value added (constant 2005 US$) of East Asia (all income levels) and Value added (constant 2005 US$) of Peru?
Offer a very short reply. 1.95e+12. In the year 1978, what is the difference between the Value added (constant 2005 US$) in East Asia (all income levels) and Value added (constant 2005 US$) in Zambia?
Provide a short and direct response. 1.97e+12. In the year 1978, what is the difference between the Value added (constant 2005 US$) of Upper middle income and Value added (constant 2005 US$) of Peru?
Your answer should be very brief. 8.84e+11. In the year 1978, what is the difference between the Value added (constant 2005 US$) in Upper middle income and Value added (constant 2005 US$) in Zambia?
Offer a terse response. 9.05e+11. In the year 1978, what is the difference between the Value added (constant 2005 US$) of Peru and Value added (constant 2005 US$) of Zambia?
Your response must be concise. 2.09e+1. In the year 1979, what is the difference between the Value added (constant 2005 US$) in East Asia (all income levels) and Value added (constant 2005 US$) in Upper middle income?
Offer a terse response. 1.14e+12. In the year 1979, what is the difference between the Value added (constant 2005 US$) of East Asia (all income levels) and Value added (constant 2005 US$) of Peru?
Provide a succinct answer. 2.08e+12. In the year 1979, what is the difference between the Value added (constant 2005 US$) of East Asia (all income levels) and Value added (constant 2005 US$) of Zambia?
Make the answer very short. 2.10e+12. In the year 1979, what is the difference between the Value added (constant 2005 US$) in Upper middle income and Value added (constant 2005 US$) in Peru?
Make the answer very short. 9.44e+11. In the year 1979, what is the difference between the Value added (constant 2005 US$) of Upper middle income and Value added (constant 2005 US$) of Zambia?
Provide a short and direct response. 9.65e+11. In the year 1979, what is the difference between the Value added (constant 2005 US$) in Peru and Value added (constant 2005 US$) in Zambia?
Your response must be concise. 2.12e+1. In the year 1980, what is the difference between the Value added (constant 2005 US$) in East Asia (all income levels) and Value added (constant 2005 US$) in Upper middle income?
Your answer should be very brief. 1.20e+12. In the year 1980, what is the difference between the Value added (constant 2005 US$) in East Asia (all income levels) and Value added (constant 2005 US$) in Peru?
Make the answer very short. 2.20e+12. In the year 1980, what is the difference between the Value added (constant 2005 US$) in East Asia (all income levels) and Value added (constant 2005 US$) in Zambia?
Give a very brief answer. 2.22e+12. In the year 1980, what is the difference between the Value added (constant 2005 US$) in Upper middle income and Value added (constant 2005 US$) in Peru?
Your answer should be compact. 1.00e+12. In the year 1980, what is the difference between the Value added (constant 2005 US$) of Upper middle income and Value added (constant 2005 US$) of Zambia?
Provide a short and direct response. 1.03e+12. In the year 1980, what is the difference between the Value added (constant 2005 US$) in Peru and Value added (constant 2005 US$) in Zambia?
Give a very brief answer. 2.44e+1. In the year 1981, what is the difference between the Value added (constant 2005 US$) of East Asia (all income levels) and Value added (constant 2005 US$) of Upper middle income?
Provide a short and direct response. 1.21e+12. In the year 1981, what is the difference between the Value added (constant 2005 US$) of East Asia (all income levels) and Value added (constant 2005 US$) of Peru?
Your answer should be very brief. 2.28e+12. In the year 1981, what is the difference between the Value added (constant 2005 US$) of East Asia (all income levels) and Value added (constant 2005 US$) of Zambia?
Keep it short and to the point. 2.31e+12. In the year 1981, what is the difference between the Value added (constant 2005 US$) of Upper middle income and Value added (constant 2005 US$) of Peru?
Your answer should be compact. 1.07e+12. In the year 1981, what is the difference between the Value added (constant 2005 US$) in Upper middle income and Value added (constant 2005 US$) in Zambia?
Offer a terse response. 1.09e+12. In the year 1981, what is the difference between the Value added (constant 2005 US$) of Peru and Value added (constant 2005 US$) of Zambia?
Your answer should be compact. 2.67e+1. In the year 1982, what is the difference between the Value added (constant 2005 US$) of East Asia (all income levels) and Value added (constant 2005 US$) of Upper middle income?
Your answer should be compact. 1.27e+12. In the year 1982, what is the difference between the Value added (constant 2005 US$) of East Asia (all income levels) and Value added (constant 2005 US$) of Peru?
Give a very brief answer. 2.37e+12. In the year 1982, what is the difference between the Value added (constant 2005 US$) of East Asia (all income levels) and Value added (constant 2005 US$) of Zambia?
Provide a succinct answer. 2.39e+12. In the year 1982, what is the difference between the Value added (constant 2005 US$) in Upper middle income and Value added (constant 2005 US$) in Peru?
Offer a terse response. 1.10e+12. In the year 1982, what is the difference between the Value added (constant 2005 US$) in Upper middle income and Value added (constant 2005 US$) in Zambia?
Offer a very short reply. 1.12e+12. In the year 1982, what is the difference between the Value added (constant 2005 US$) of Peru and Value added (constant 2005 US$) of Zambia?
Offer a terse response. 2.66e+1. In the year 1983, what is the difference between the Value added (constant 2005 US$) of East Asia (all income levels) and Value added (constant 2005 US$) of Upper middle income?
Provide a short and direct response. 1.34e+12. In the year 1983, what is the difference between the Value added (constant 2005 US$) in East Asia (all income levels) and Value added (constant 2005 US$) in Peru?
Ensure brevity in your answer.  2.47e+12. In the year 1983, what is the difference between the Value added (constant 2005 US$) of East Asia (all income levels) and Value added (constant 2005 US$) of Zambia?
Your answer should be very brief. 2.50e+12. In the year 1983, what is the difference between the Value added (constant 2005 US$) in Upper middle income and Value added (constant 2005 US$) in Peru?
Your answer should be very brief. 1.13e+12. In the year 1983, what is the difference between the Value added (constant 2005 US$) of Upper middle income and Value added (constant 2005 US$) of Zambia?
Offer a terse response. 1.15e+12. In the year 1983, what is the difference between the Value added (constant 2005 US$) in Peru and Value added (constant 2005 US$) in Zambia?
Offer a very short reply. 2.47e+1. What is the ratio of the Value added (constant 2005 US$) in Upper middle income in 1977 to that in 1978?
Provide a succinct answer. 0.94. What is the ratio of the Value added (constant 2005 US$) in Peru in 1977 to that in 1978?
Your answer should be compact. 1.05. What is the ratio of the Value added (constant 2005 US$) in Zambia in 1977 to that in 1978?
Offer a very short reply. 1.07. What is the ratio of the Value added (constant 2005 US$) of East Asia (all income levels) in 1977 to that in 1979?
Provide a short and direct response. 0.89. What is the ratio of the Value added (constant 2005 US$) of Upper middle income in 1977 to that in 1979?
Make the answer very short. 0.89. What is the ratio of the Value added (constant 2005 US$) of Peru in 1977 to that in 1979?
Your response must be concise. 1.03. What is the ratio of the Value added (constant 2005 US$) in Zambia in 1977 to that in 1979?
Offer a terse response. 1.03. What is the ratio of the Value added (constant 2005 US$) in East Asia (all income levels) in 1977 to that in 1980?
Provide a succinct answer. 0.84. What is the ratio of the Value added (constant 2005 US$) in Upper middle income in 1977 to that in 1980?
Your answer should be very brief. 0.83. What is the ratio of the Value added (constant 2005 US$) in Peru in 1977 to that in 1980?
Keep it short and to the point. 0.9. What is the ratio of the Value added (constant 2005 US$) in Zambia in 1977 to that in 1980?
Your response must be concise. 0.93. What is the ratio of the Value added (constant 2005 US$) of East Asia (all income levels) in 1977 to that in 1981?
Provide a succinct answer. 0.81. What is the ratio of the Value added (constant 2005 US$) in Upper middle income in 1977 to that in 1981?
Make the answer very short. 0.78. What is the ratio of the Value added (constant 2005 US$) in Peru in 1977 to that in 1981?
Provide a succinct answer. 0.83. What is the ratio of the Value added (constant 2005 US$) in Zambia in 1977 to that in 1981?
Keep it short and to the point. 0.87. What is the ratio of the Value added (constant 2005 US$) in East Asia (all income levels) in 1977 to that in 1982?
Make the answer very short. 0.78. What is the ratio of the Value added (constant 2005 US$) in Upper middle income in 1977 to that in 1982?
Your answer should be compact. 0.76. What is the ratio of the Value added (constant 2005 US$) of Peru in 1977 to that in 1982?
Your answer should be very brief. 0.83. What is the ratio of the Value added (constant 2005 US$) of Zambia in 1977 to that in 1982?
Your answer should be very brief. 0.93. What is the ratio of the Value added (constant 2005 US$) of East Asia (all income levels) in 1977 to that in 1983?
Offer a terse response. 0.75. What is the ratio of the Value added (constant 2005 US$) of Upper middle income in 1977 to that in 1983?
Keep it short and to the point. 0.74. What is the ratio of the Value added (constant 2005 US$) of Peru in 1977 to that in 1983?
Provide a short and direct response. 0.9. What is the ratio of the Value added (constant 2005 US$) in Zambia in 1977 to that in 1983?
Make the answer very short. 1.03. What is the ratio of the Value added (constant 2005 US$) in East Asia (all income levels) in 1978 to that in 1979?
Your response must be concise. 0.94. What is the ratio of the Value added (constant 2005 US$) in Upper middle income in 1978 to that in 1979?
Ensure brevity in your answer.  0.94. What is the ratio of the Value added (constant 2005 US$) of Zambia in 1978 to that in 1979?
Your response must be concise. 0.96. What is the ratio of the Value added (constant 2005 US$) of East Asia (all income levels) in 1978 to that in 1980?
Your response must be concise. 0.89. What is the ratio of the Value added (constant 2005 US$) in Upper middle income in 1978 to that in 1980?
Your answer should be very brief. 0.88. What is the ratio of the Value added (constant 2005 US$) of Peru in 1978 to that in 1980?
Your answer should be compact. 0.86. What is the ratio of the Value added (constant 2005 US$) in Zambia in 1978 to that in 1980?
Your answer should be very brief. 0.87. What is the ratio of the Value added (constant 2005 US$) of East Asia (all income levels) in 1978 to that in 1981?
Keep it short and to the point. 0.85. What is the ratio of the Value added (constant 2005 US$) of Upper middle income in 1978 to that in 1981?
Provide a short and direct response. 0.83. What is the ratio of the Value added (constant 2005 US$) in Peru in 1978 to that in 1981?
Your answer should be very brief. 0.78. What is the ratio of the Value added (constant 2005 US$) of Zambia in 1978 to that in 1981?
Provide a succinct answer. 0.81. What is the ratio of the Value added (constant 2005 US$) in East Asia (all income levels) in 1978 to that in 1982?
Your answer should be compact. 0.82. What is the ratio of the Value added (constant 2005 US$) in Upper middle income in 1978 to that in 1982?
Offer a very short reply. 0.8. What is the ratio of the Value added (constant 2005 US$) in Peru in 1978 to that in 1982?
Ensure brevity in your answer.  0.79. What is the ratio of the Value added (constant 2005 US$) in Zambia in 1978 to that in 1982?
Your response must be concise. 0.87. What is the ratio of the Value added (constant 2005 US$) in East Asia (all income levels) in 1978 to that in 1983?
Provide a succinct answer. 0.79. What is the ratio of the Value added (constant 2005 US$) of Upper middle income in 1978 to that in 1983?
Ensure brevity in your answer.  0.79. What is the ratio of the Value added (constant 2005 US$) in Peru in 1978 to that in 1983?
Make the answer very short. 0.85. What is the ratio of the Value added (constant 2005 US$) of Zambia in 1978 to that in 1983?
Give a very brief answer. 0.97. What is the ratio of the Value added (constant 2005 US$) of East Asia (all income levels) in 1979 to that in 1980?
Give a very brief answer. 0.95. What is the ratio of the Value added (constant 2005 US$) in Upper middle income in 1979 to that in 1980?
Offer a terse response. 0.94. What is the ratio of the Value added (constant 2005 US$) of Peru in 1979 to that in 1980?
Offer a very short reply. 0.87. What is the ratio of the Value added (constant 2005 US$) of Zambia in 1979 to that in 1980?
Your answer should be very brief. 0.91. What is the ratio of the Value added (constant 2005 US$) in East Asia (all income levels) in 1979 to that in 1981?
Ensure brevity in your answer.  0.91. What is the ratio of the Value added (constant 2005 US$) in Upper middle income in 1979 to that in 1981?
Offer a very short reply. 0.88. What is the ratio of the Value added (constant 2005 US$) of Peru in 1979 to that in 1981?
Your response must be concise. 0.8. What is the ratio of the Value added (constant 2005 US$) in Zambia in 1979 to that in 1981?
Ensure brevity in your answer.  0.84. What is the ratio of the Value added (constant 2005 US$) of East Asia (all income levels) in 1979 to that in 1982?
Your answer should be very brief. 0.88. What is the ratio of the Value added (constant 2005 US$) in Upper middle income in 1979 to that in 1982?
Keep it short and to the point. 0.86. What is the ratio of the Value added (constant 2005 US$) of Peru in 1979 to that in 1982?
Offer a terse response. 0.81. What is the ratio of the Value added (constant 2005 US$) in Zambia in 1979 to that in 1982?
Ensure brevity in your answer.  0.91. What is the ratio of the Value added (constant 2005 US$) of East Asia (all income levels) in 1979 to that in 1983?
Give a very brief answer. 0.84. What is the ratio of the Value added (constant 2005 US$) in Upper middle income in 1979 to that in 1983?
Provide a short and direct response. 0.84. What is the ratio of the Value added (constant 2005 US$) of Peru in 1979 to that in 1983?
Provide a succinct answer. 0.87. What is the ratio of the Value added (constant 2005 US$) of Zambia in 1979 to that in 1983?
Your response must be concise. 1.01. What is the ratio of the Value added (constant 2005 US$) in East Asia (all income levels) in 1980 to that in 1981?
Your answer should be very brief. 0.96. What is the ratio of the Value added (constant 2005 US$) of Upper middle income in 1980 to that in 1981?
Your answer should be compact. 0.94. What is the ratio of the Value added (constant 2005 US$) in Peru in 1980 to that in 1981?
Your response must be concise. 0.92. What is the ratio of the Value added (constant 2005 US$) of Zambia in 1980 to that in 1981?
Your answer should be compact. 0.93. What is the ratio of the Value added (constant 2005 US$) of East Asia (all income levels) in 1980 to that in 1982?
Keep it short and to the point. 0.93. What is the ratio of the Value added (constant 2005 US$) of Upper middle income in 1980 to that in 1982?
Offer a terse response. 0.91. What is the ratio of the Value added (constant 2005 US$) of Peru in 1980 to that in 1982?
Provide a succinct answer. 0.92. What is the ratio of the Value added (constant 2005 US$) in East Asia (all income levels) in 1980 to that in 1983?
Offer a terse response. 0.89. What is the ratio of the Value added (constant 2005 US$) in Upper middle income in 1980 to that in 1983?
Provide a short and direct response. 0.89. What is the ratio of the Value added (constant 2005 US$) of Peru in 1980 to that in 1983?
Offer a very short reply. 1. What is the ratio of the Value added (constant 2005 US$) of Zambia in 1980 to that in 1983?
Your response must be concise. 1.11. What is the ratio of the Value added (constant 2005 US$) of Upper middle income in 1981 to that in 1982?
Provide a succinct answer. 0.97. What is the ratio of the Value added (constant 2005 US$) in Peru in 1981 to that in 1982?
Offer a terse response. 1.01. What is the ratio of the Value added (constant 2005 US$) in Zambia in 1981 to that in 1982?
Your answer should be very brief. 1.08. What is the ratio of the Value added (constant 2005 US$) of East Asia (all income levels) in 1981 to that in 1983?
Make the answer very short. 0.92. What is the ratio of the Value added (constant 2005 US$) of Peru in 1981 to that in 1983?
Make the answer very short. 1.09. What is the ratio of the Value added (constant 2005 US$) in Zambia in 1981 to that in 1983?
Your response must be concise. 1.19. What is the ratio of the Value added (constant 2005 US$) of East Asia (all income levels) in 1982 to that in 1983?
Ensure brevity in your answer.  0.96. What is the ratio of the Value added (constant 2005 US$) in Peru in 1982 to that in 1983?
Your response must be concise. 1.08. What is the ratio of the Value added (constant 2005 US$) of Zambia in 1982 to that in 1983?
Offer a very short reply. 1.11. What is the difference between the highest and the second highest Value added (constant 2005 US$) in East Asia (all income levels)?
Keep it short and to the point. 1.04e+11. What is the difference between the highest and the second highest Value added (constant 2005 US$) in Upper middle income?
Provide a short and direct response. 2.77e+1. What is the difference between the highest and the second highest Value added (constant 2005 US$) in Peru?
Give a very brief answer. 2.77e+08. What is the difference between the highest and the second highest Value added (constant 2005 US$) in Zambia?
Your response must be concise. 1.66e+08. What is the difference between the highest and the lowest Value added (constant 2005 US$) of East Asia (all income levels)?
Give a very brief answer. 6.26e+11. What is the difference between the highest and the lowest Value added (constant 2005 US$) in Upper middle income?
Your answer should be compact. 2.98e+11. What is the difference between the highest and the lowest Value added (constant 2005 US$) in Peru?
Provide a short and direct response. 6.31e+09. What is the difference between the highest and the lowest Value added (constant 2005 US$) of Zambia?
Give a very brief answer. 4.61e+08. 